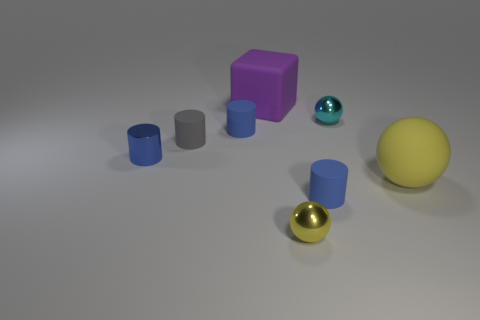Subtract all gray cubes. How many blue cylinders are left? 3 Add 1 red rubber cylinders. How many objects exist? 9 Subtract all spheres. How many objects are left? 5 Add 8 big purple matte things. How many big purple matte things are left? 9 Add 4 yellow matte things. How many yellow matte things exist? 5 Subtract 0 red cylinders. How many objects are left? 8 Subtract all cyan objects. Subtract all cyan objects. How many objects are left? 6 